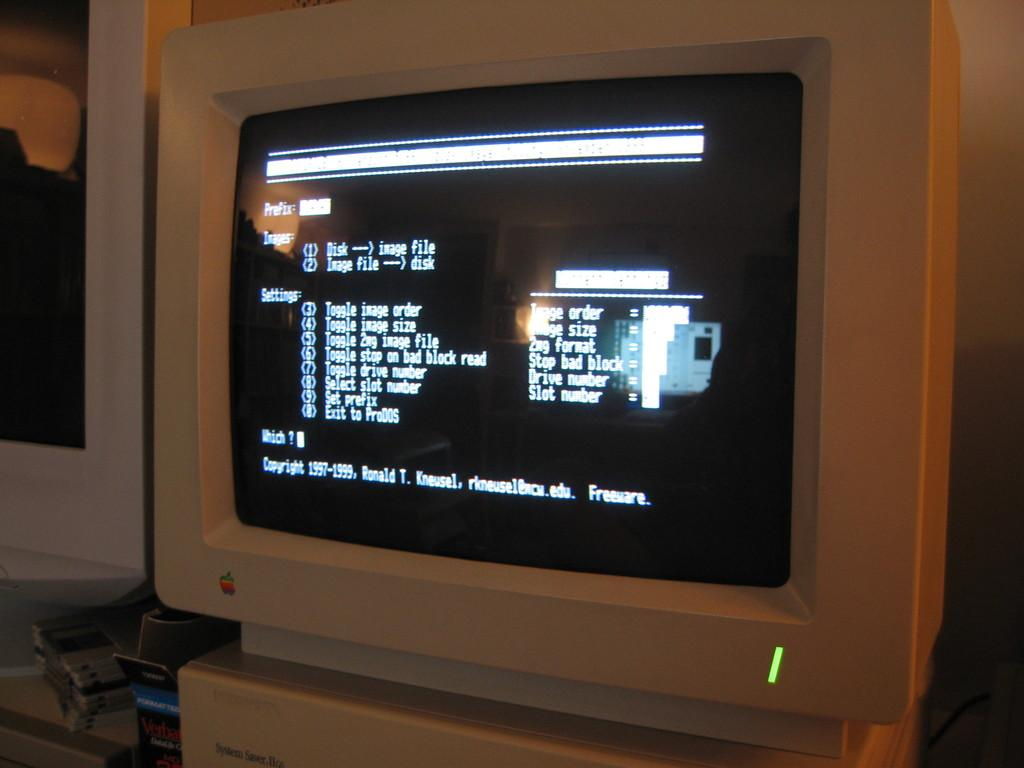Provide a one-sentence caption for the provided image. A old white Apple computer turned on with aa green power light . 